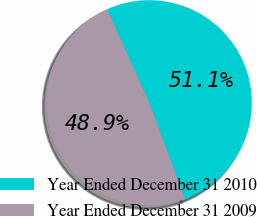Convert chart. <chart><loc_0><loc_0><loc_500><loc_500><pie_chart><fcel>Year Ended December 31 2010<fcel>Year Ended December 31 2009<nl><fcel>51.06%<fcel>48.94%<nl></chart> 